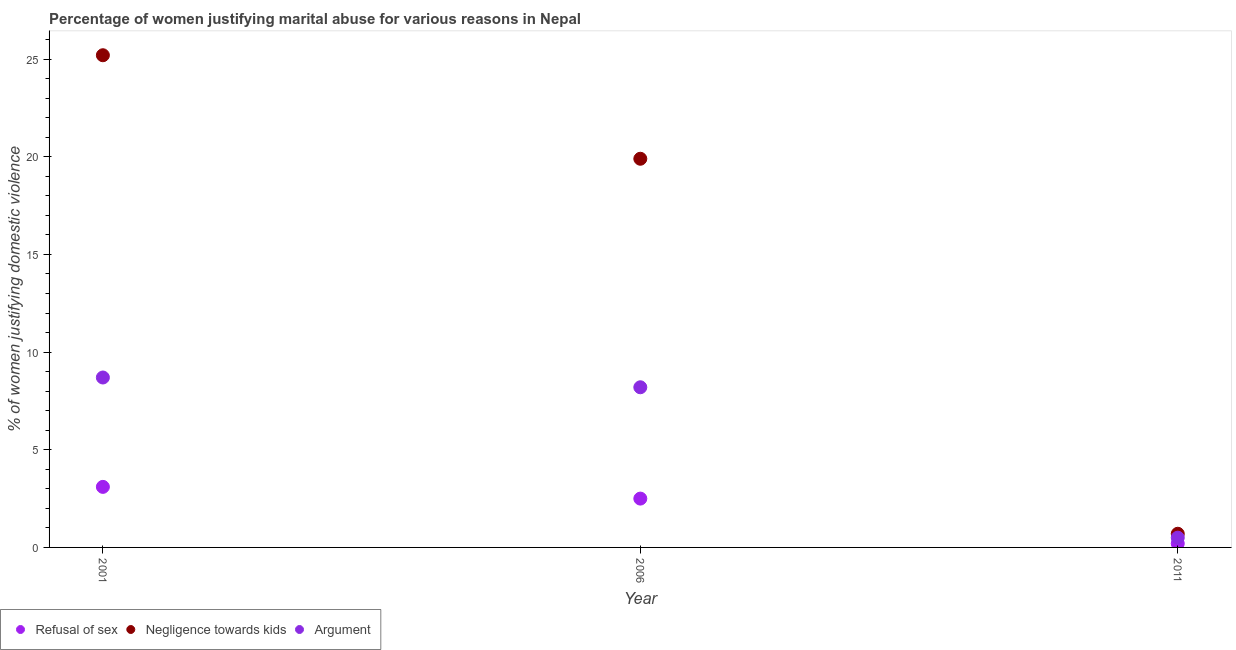How many different coloured dotlines are there?
Ensure brevity in your answer.  3. Is the number of dotlines equal to the number of legend labels?
Offer a terse response. Yes. Across all years, what is the maximum percentage of women justifying domestic violence due to negligence towards kids?
Provide a short and direct response. 25.2. Across all years, what is the minimum percentage of women justifying domestic violence due to arguments?
Keep it short and to the point. 0.5. What is the difference between the percentage of women justifying domestic violence due to arguments in 2011 and the percentage of women justifying domestic violence due to negligence towards kids in 2006?
Provide a succinct answer. -19.4. In the year 2011, what is the difference between the percentage of women justifying domestic violence due to arguments and percentage of women justifying domestic violence due to refusal of sex?
Offer a very short reply. 0.3. In how many years, is the percentage of women justifying domestic violence due to refusal of sex greater than 2 %?
Give a very brief answer. 2. Is the difference between the percentage of women justifying domestic violence due to refusal of sex in 2006 and 2011 greater than the difference between the percentage of women justifying domestic violence due to negligence towards kids in 2006 and 2011?
Your response must be concise. No. What is the difference between the highest and the second highest percentage of women justifying domestic violence due to negligence towards kids?
Your answer should be compact. 5.3. In how many years, is the percentage of women justifying domestic violence due to negligence towards kids greater than the average percentage of women justifying domestic violence due to negligence towards kids taken over all years?
Your answer should be compact. 2. Is the sum of the percentage of women justifying domestic violence due to arguments in 2006 and 2011 greater than the maximum percentage of women justifying domestic violence due to refusal of sex across all years?
Make the answer very short. Yes. Is the percentage of women justifying domestic violence due to refusal of sex strictly greater than the percentage of women justifying domestic violence due to arguments over the years?
Provide a succinct answer. No. Is the percentage of women justifying domestic violence due to negligence towards kids strictly less than the percentage of women justifying domestic violence due to arguments over the years?
Make the answer very short. No. How many dotlines are there?
Offer a very short reply. 3. How many years are there in the graph?
Your answer should be compact. 3. What is the title of the graph?
Your answer should be compact. Percentage of women justifying marital abuse for various reasons in Nepal. Does "Agricultural raw materials" appear as one of the legend labels in the graph?
Offer a terse response. No. What is the label or title of the X-axis?
Provide a short and direct response. Year. What is the label or title of the Y-axis?
Make the answer very short. % of women justifying domestic violence. What is the % of women justifying domestic violence of Refusal of sex in 2001?
Your answer should be very brief. 3.1. What is the % of women justifying domestic violence of Negligence towards kids in 2001?
Your answer should be very brief. 25.2. What is the % of women justifying domestic violence in Argument in 2001?
Provide a short and direct response. 8.7. What is the % of women justifying domestic violence of Argument in 2006?
Give a very brief answer. 8.2. What is the % of women justifying domestic violence of Negligence towards kids in 2011?
Keep it short and to the point. 0.7. What is the % of women justifying domestic violence in Argument in 2011?
Offer a very short reply. 0.5. Across all years, what is the maximum % of women justifying domestic violence of Negligence towards kids?
Keep it short and to the point. 25.2. Across all years, what is the maximum % of women justifying domestic violence of Argument?
Provide a short and direct response. 8.7. Across all years, what is the minimum % of women justifying domestic violence of Argument?
Provide a succinct answer. 0.5. What is the total % of women justifying domestic violence of Negligence towards kids in the graph?
Offer a terse response. 45.8. What is the total % of women justifying domestic violence in Argument in the graph?
Your response must be concise. 17.4. What is the difference between the % of women justifying domestic violence in Argument in 2006 and that in 2011?
Provide a short and direct response. 7.7. What is the difference between the % of women justifying domestic violence of Refusal of sex in 2001 and the % of women justifying domestic violence of Negligence towards kids in 2006?
Provide a short and direct response. -16.8. What is the difference between the % of women justifying domestic violence of Refusal of sex in 2001 and the % of women justifying domestic violence of Argument in 2006?
Provide a short and direct response. -5.1. What is the difference between the % of women justifying domestic violence in Refusal of sex in 2001 and the % of women justifying domestic violence in Argument in 2011?
Give a very brief answer. 2.6. What is the difference between the % of women justifying domestic violence of Negligence towards kids in 2001 and the % of women justifying domestic violence of Argument in 2011?
Your answer should be very brief. 24.7. What is the difference between the % of women justifying domestic violence in Negligence towards kids in 2006 and the % of women justifying domestic violence in Argument in 2011?
Provide a succinct answer. 19.4. What is the average % of women justifying domestic violence of Refusal of sex per year?
Provide a short and direct response. 1.93. What is the average % of women justifying domestic violence in Negligence towards kids per year?
Your answer should be very brief. 15.27. In the year 2001, what is the difference between the % of women justifying domestic violence of Refusal of sex and % of women justifying domestic violence of Negligence towards kids?
Give a very brief answer. -22.1. In the year 2006, what is the difference between the % of women justifying domestic violence of Refusal of sex and % of women justifying domestic violence of Negligence towards kids?
Your answer should be very brief. -17.4. In the year 2006, what is the difference between the % of women justifying domestic violence in Refusal of sex and % of women justifying domestic violence in Argument?
Offer a terse response. -5.7. In the year 2011, what is the difference between the % of women justifying domestic violence in Refusal of sex and % of women justifying domestic violence in Negligence towards kids?
Make the answer very short. -0.5. What is the ratio of the % of women justifying domestic violence of Refusal of sex in 2001 to that in 2006?
Make the answer very short. 1.24. What is the ratio of the % of women justifying domestic violence in Negligence towards kids in 2001 to that in 2006?
Offer a terse response. 1.27. What is the ratio of the % of women justifying domestic violence in Argument in 2001 to that in 2006?
Give a very brief answer. 1.06. What is the ratio of the % of women justifying domestic violence in Refusal of sex in 2001 to that in 2011?
Provide a succinct answer. 15.5. What is the ratio of the % of women justifying domestic violence of Negligence towards kids in 2001 to that in 2011?
Your response must be concise. 36. What is the ratio of the % of women justifying domestic violence of Argument in 2001 to that in 2011?
Provide a succinct answer. 17.4. What is the ratio of the % of women justifying domestic violence of Negligence towards kids in 2006 to that in 2011?
Offer a very short reply. 28.43. What is the difference between the highest and the second highest % of women justifying domestic violence of Negligence towards kids?
Ensure brevity in your answer.  5.3. What is the difference between the highest and the second highest % of women justifying domestic violence of Argument?
Give a very brief answer. 0.5. What is the difference between the highest and the lowest % of women justifying domestic violence of Argument?
Provide a succinct answer. 8.2. 